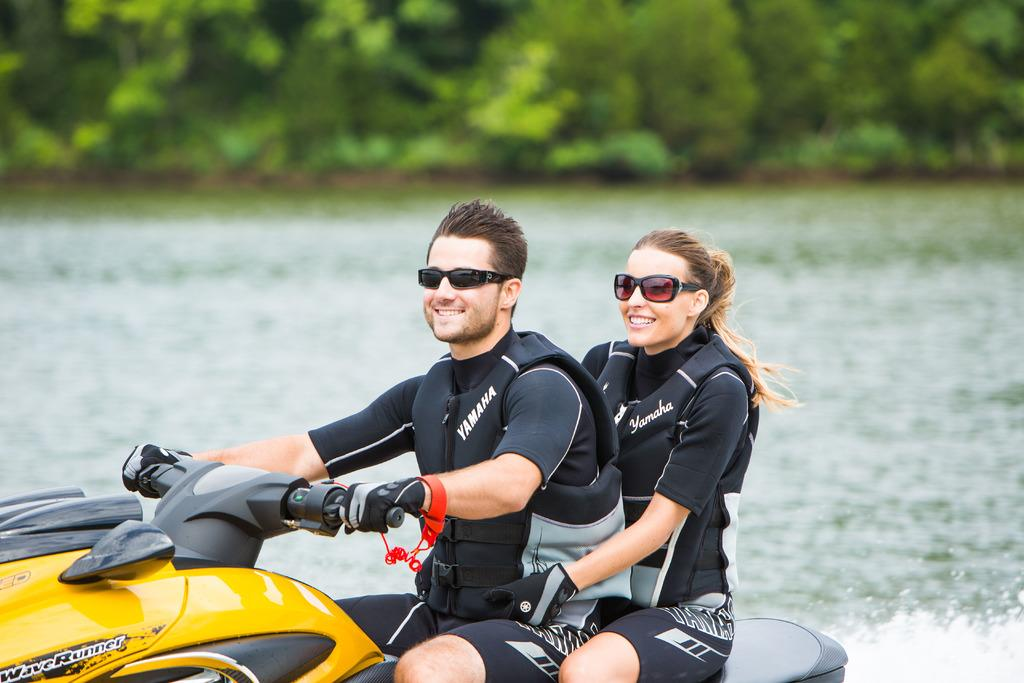What can be seen in the foreground of the image? There are people and watercraft in the foreground of the image. What is visible in the background of the image? There is water and trees visible in the background of the image. What type of chalk is being used by the people in the image? There is no chalk present in the image. What observation can be made about the people's behavior in the image? The provided facts do not give any information about the people's behavior, so it is not possible to make an observation about it. 